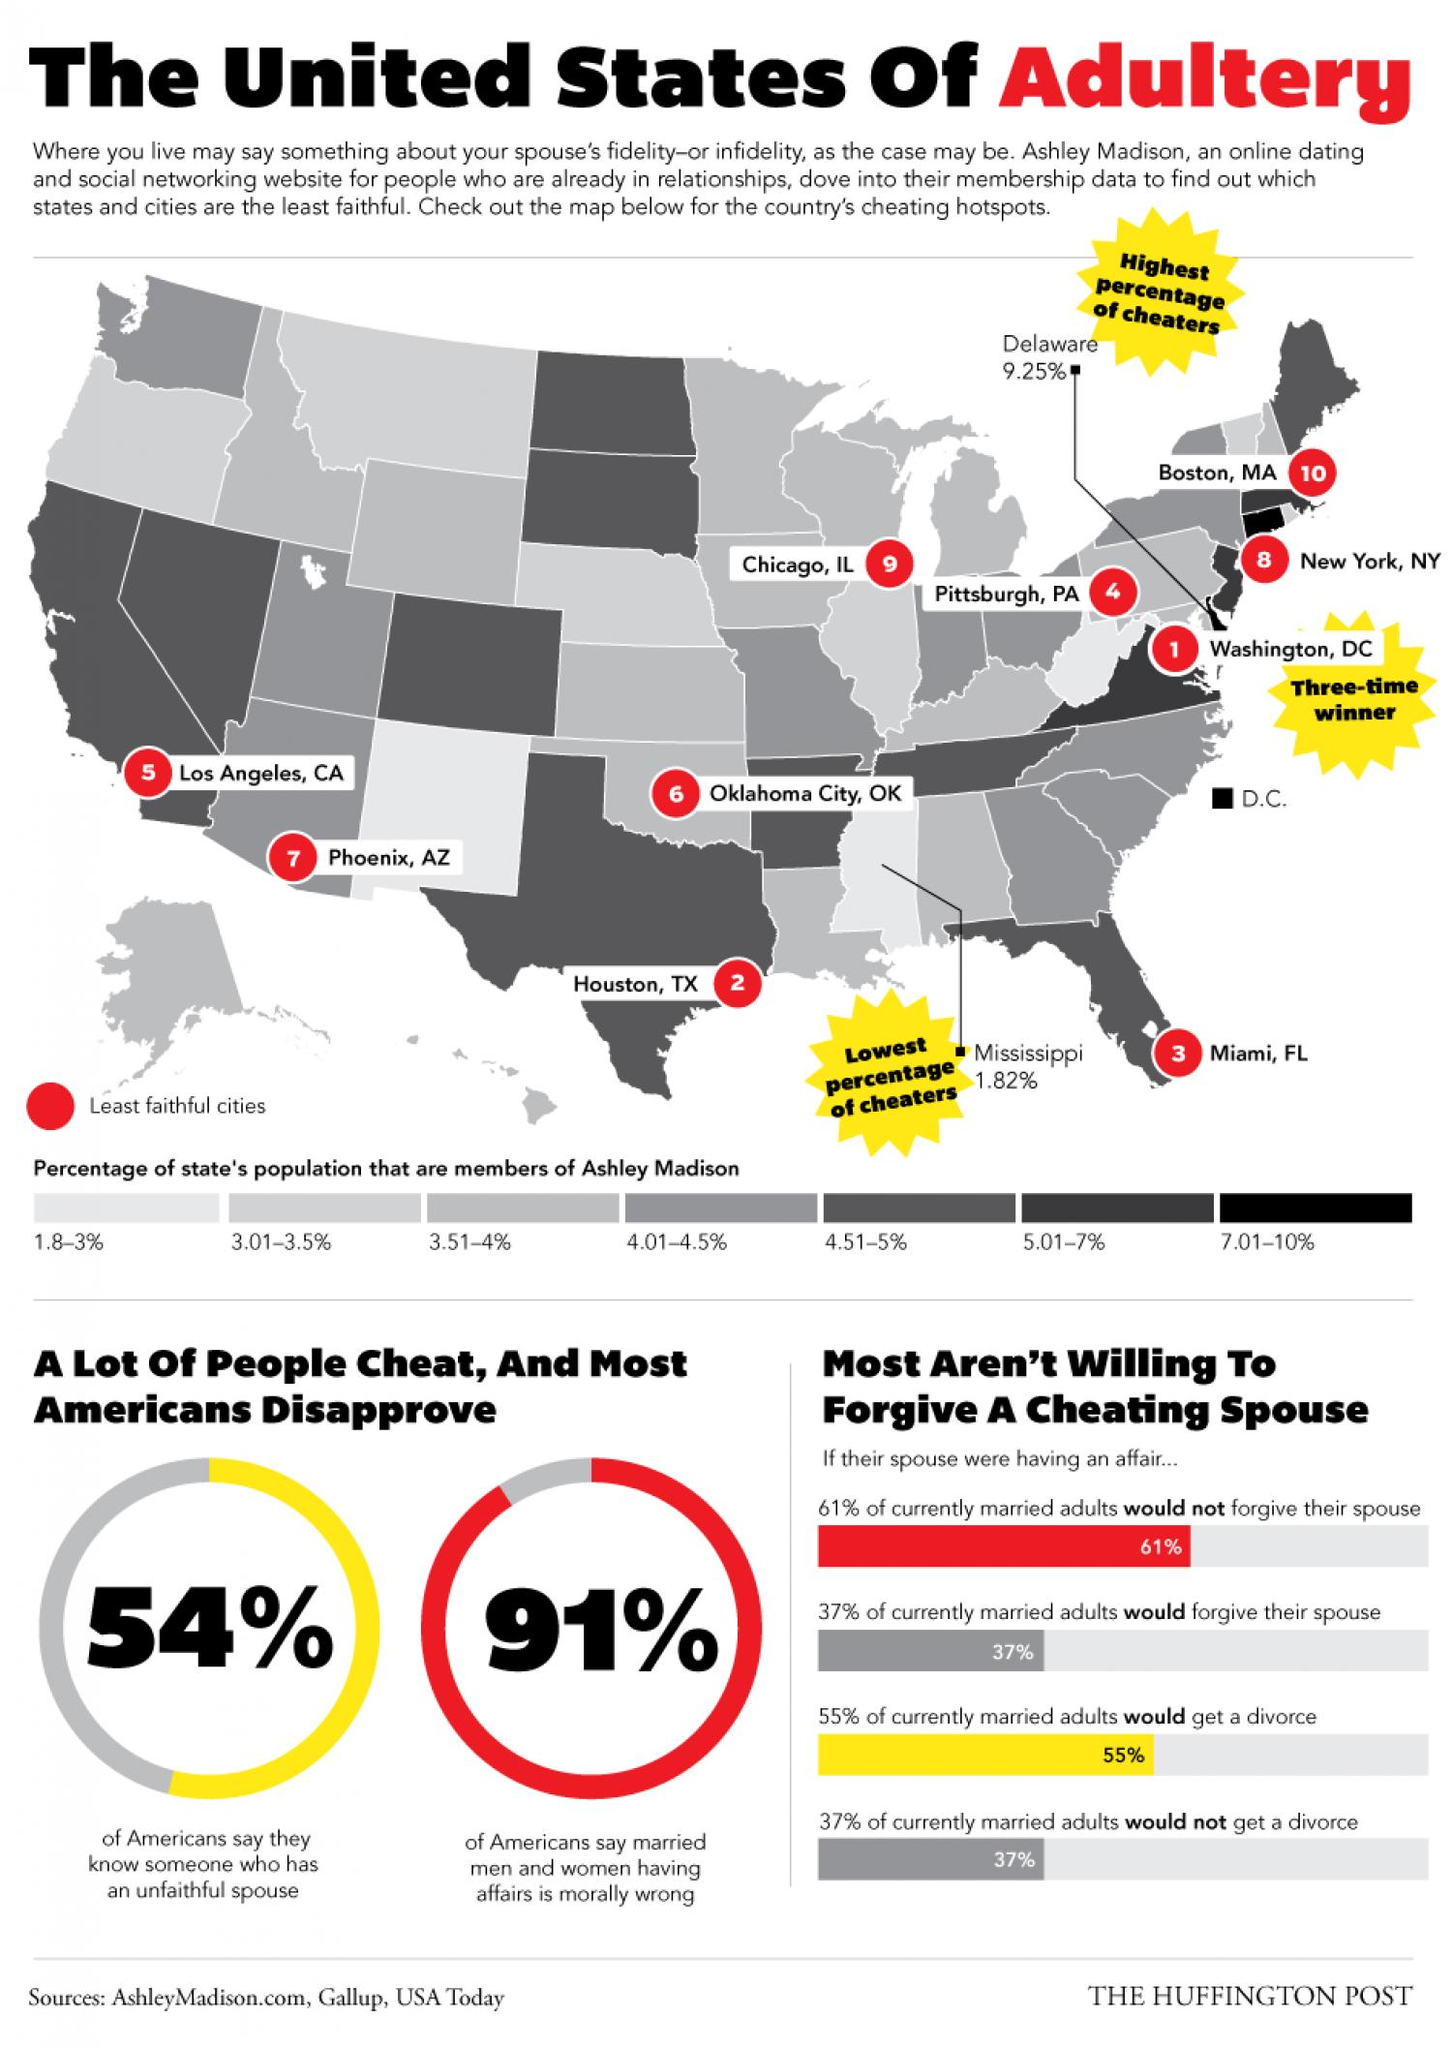Specify some key components in this picture. According to a recent survey, 9% of Americans do not believe that married men and women having affairs is morally wrong. 